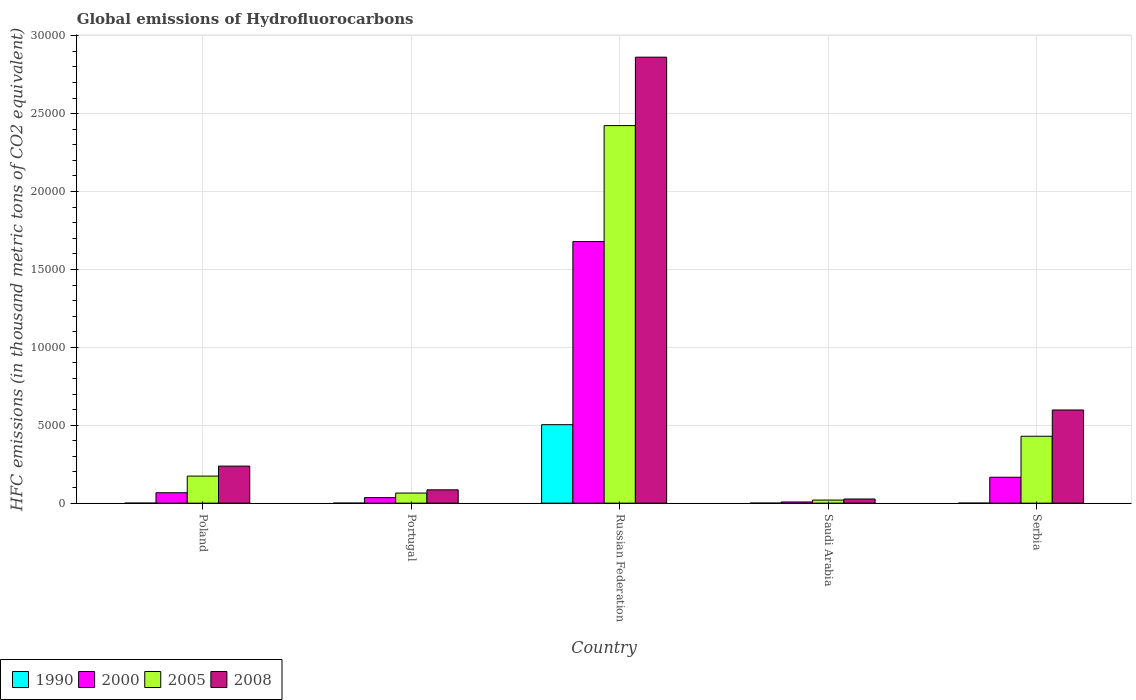How many different coloured bars are there?
Make the answer very short. 4. How many groups of bars are there?
Give a very brief answer. 5. How many bars are there on the 2nd tick from the left?
Make the answer very short. 4. What is the label of the 4th group of bars from the left?
Make the answer very short. Saudi Arabia. In how many cases, is the number of bars for a given country not equal to the number of legend labels?
Your answer should be compact. 0. What is the global emissions of Hydrofluorocarbons in 1990 in Poland?
Provide a succinct answer. 0.1. Across all countries, what is the maximum global emissions of Hydrofluorocarbons in 1990?
Provide a short and direct response. 5035.6. Across all countries, what is the minimum global emissions of Hydrofluorocarbons in 2005?
Offer a terse response. 196.9. In which country was the global emissions of Hydrofluorocarbons in 2008 maximum?
Your answer should be very brief. Russian Federation. In which country was the global emissions of Hydrofluorocarbons in 2000 minimum?
Your response must be concise. Saudi Arabia. What is the total global emissions of Hydrofluorocarbons in 2005 in the graph?
Your response must be concise. 3.11e+04. What is the difference between the global emissions of Hydrofluorocarbons in 2008 in Poland and that in Russian Federation?
Your answer should be compact. -2.62e+04. What is the difference between the global emissions of Hydrofluorocarbons in 1990 in Portugal and the global emissions of Hydrofluorocarbons in 2005 in Saudi Arabia?
Your response must be concise. -196.7. What is the average global emissions of Hydrofluorocarbons in 1990 per country?
Provide a short and direct response. 1007.3. What is the difference between the global emissions of Hydrofluorocarbons of/in 2000 and global emissions of Hydrofluorocarbons of/in 2005 in Russian Federation?
Your response must be concise. -7442.6. What is the ratio of the global emissions of Hydrofluorocarbons in 2008 in Poland to that in Saudi Arabia?
Provide a succinct answer. 8.92. Is the difference between the global emissions of Hydrofluorocarbons in 2000 in Russian Federation and Saudi Arabia greater than the difference between the global emissions of Hydrofluorocarbons in 2005 in Russian Federation and Saudi Arabia?
Make the answer very short. No. What is the difference between the highest and the second highest global emissions of Hydrofluorocarbons in 1990?
Provide a short and direct response. -5035.1. What is the difference between the highest and the lowest global emissions of Hydrofluorocarbons in 2000?
Keep it short and to the point. 1.67e+04. In how many countries, is the global emissions of Hydrofluorocarbons in 2005 greater than the average global emissions of Hydrofluorocarbons in 2005 taken over all countries?
Keep it short and to the point. 1. Is the sum of the global emissions of Hydrofluorocarbons in 1990 in Portugal and Russian Federation greater than the maximum global emissions of Hydrofluorocarbons in 2008 across all countries?
Your answer should be very brief. No. Is it the case that in every country, the sum of the global emissions of Hydrofluorocarbons in 2008 and global emissions of Hydrofluorocarbons in 2005 is greater than the sum of global emissions of Hydrofluorocarbons in 1990 and global emissions of Hydrofluorocarbons in 2000?
Make the answer very short. No. What does the 4th bar from the right in Poland represents?
Make the answer very short. 1990. Is it the case that in every country, the sum of the global emissions of Hydrofluorocarbons in 1990 and global emissions of Hydrofluorocarbons in 2008 is greater than the global emissions of Hydrofluorocarbons in 2005?
Provide a succinct answer. Yes. Are all the bars in the graph horizontal?
Provide a succinct answer. No. What is the difference between two consecutive major ticks on the Y-axis?
Provide a succinct answer. 5000. Are the values on the major ticks of Y-axis written in scientific E-notation?
Provide a succinct answer. No. Does the graph contain any zero values?
Provide a succinct answer. No. Does the graph contain grids?
Your answer should be very brief. Yes. Where does the legend appear in the graph?
Offer a very short reply. Bottom left. How are the legend labels stacked?
Keep it short and to the point. Horizontal. What is the title of the graph?
Make the answer very short. Global emissions of Hydrofluorocarbons. Does "1973" appear as one of the legend labels in the graph?
Your answer should be very brief. No. What is the label or title of the Y-axis?
Ensure brevity in your answer.  HFC emissions (in thousand metric tons of CO2 equivalent). What is the HFC emissions (in thousand metric tons of CO2 equivalent) in 2000 in Poland?
Provide a succinct answer. 667.2. What is the HFC emissions (in thousand metric tons of CO2 equivalent) of 2005 in Poland?
Keep it short and to the point. 1736.7. What is the HFC emissions (in thousand metric tons of CO2 equivalent) of 2008 in Poland?
Ensure brevity in your answer.  2378. What is the HFC emissions (in thousand metric tons of CO2 equivalent) in 1990 in Portugal?
Keep it short and to the point. 0.2. What is the HFC emissions (in thousand metric tons of CO2 equivalent) in 2000 in Portugal?
Your response must be concise. 352.7. What is the HFC emissions (in thousand metric tons of CO2 equivalent) of 2005 in Portugal?
Your answer should be compact. 647.7. What is the HFC emissions (in thousand metric tons of CO2 equivalent) of 2008 in Portugal?
Your answer should be very brief. 854.4. What is the HFC emissions (in thousand metric tons of CO2 equivalent) in 1990 in Russian Federation?
Ensure brevity in your answer.  5035.6. What is the HFC emissions (in thousand metric tons of CO2 equivalent) of 2000 in Russian Federation?
Offer a very short reply. 1.68e+04. What is the HFC emissions (in thousand metric tons of CO2 equivalent) of 2005 in Russian Federation?
Make the answer very short. 2.42e+04. What is the HFC emissions (in thousand metric tons of CO2 equivalent) in 2008 in Russian Federation?
Your answer should be very brief. 2.86e+04. What is the HFC emissions (in thousand metric tons of CO2 equivalent) of 1990 in Saudi Arabia?
Your response must be concise. 0.1. What is the HFC emissions (in thousand metric tons of CO2 equivalent) in 2000 in Saudi Arabia?
Your answer should be very brief. 75.5. What is the HFC emissions (in thousand metric tons of CO2 equivalent) in 2005 in Saudi Arabia?
Your answer should be very brief. 196.9. What is the HFC emissions (in thousand metric tons of CO2 equivalent) in 2008 in Saudi Arabia?
Your response must be concise. 266.5. What is the HFC emissions (in thousand metric tons of CO2 equivalent) of 1990 in Serbia?
Offer a terse response. 0.5. What is the HFC emissions (in thousand metric tons of CO2 equivalent) of 2000 in Serbia?
Your response must be concise. 1662. What is the HFC emissions (in thousand metric tons of CO2 equivalent) in 2005 in Serbia?
Provide a short and direct response. 4293.8. What is the HFC emissions (in thousand metric tons of CO2 equivalent) of 2008 in Serbia?
Offer a terse response. 5979. Across all countries, what is the maximum HFC emissions (in thousand metric tons of CO2 equivalent) of 1990?
Your answer should be very brief. 5035.6. Across all countries, what is the maximum HFC emissions (in thousand metric tons of CO2 equivalent) of 2000?
Your answer should be compact. 1.68e+04. Across all countries, what is the maximum HFC emissions (in thousand metric tons of CO2 equivalent) in 2005?
Keep it short and to the point. 2.42e+04. Across all countries, what is the maximum HFC emissions (in thousand metric tons of CO2 equivalent) in 2008?
Your answer should be compact. 2.86e+04. Across all countries, what is the minimum HFC emissions (in thousand metric tons of CO2 equivalent) in 1990?
Make the answer very short. 0.1. Across all countries, what is the minimum HFC emissions (in thousand metric tons of CO2 equivalent) of 2000?
Your response must be concise. 75.5. Across all countries, what is the minimum HFC emissions (in thousand metric tons of CO2 equivalent) in 2005?
Your response must be concise. 196.9. Across all countries, what is the minimum HFC emissions (in thousand metric tons of CO2 equivalent) in 2008?
Offer a terse response. 266.5. What is the total HFC emissions (in thousand metric tons of CO2 equivalent) of 1990 in the graph?
Offer a terse response. 5036.5. What is the total HFC emissions (in thousand metric tons of CO2 equivalent) in 2000 in the graph?
Offer a very short reply. 1.95e+04. What is the total HFC emissions (in thousand metric tons of CO2 equivalent) in 2005 in the graph?
Keep it short and to the point. 3.11e+04. What is the total HFC emissions (in thousand metric tons of CO2 equivalent) in 2008 in the graph?
Your answer should be very brief. 3.81e+04. What is the difference between the HFC emissions (in thousand metric tons of CO2 equivalent) in 1990 in Poland and that in Portugal?
Make the answer very short. -0.1. What is the difference between the HFC emissions (in thousand metric tons of CO2 equivalent) of 2000 in Poland and that in Portugal?
Your response must be concise. 314.5. What is the difference between the HFC emissions (in thousand metric tons of CO2 equivalent) of 2005 in Poland and that in Portugal?
Your response must be concise. 1089. What is the difference between the HFC emissions (in thousand metric tons of CO2 equivalent) of 2008 in Poland and that in Portugal?
Provide a short and direct response. 1523.6. What is the difference between the HFC emissions (in thousand metric tons of CO2 equivalent) in 1990 in Poland and that in Russian Federation?
Ensure brevity in your answer.  -5035.5. What is the difference between the HFC emissions (in thousand metric tons of CO2 equivalent) in 2000 in Poland and that in Russian Federation?
Offer a terse response. -1.61e+04. What is the difference between the HFC emissions (in thousand metric tons of CO2 equivalent) of 2005 in Poland and that in Russian Federation?
Ensure brevity in your answer.  -2.25e+04. What is the difference between the HFC emissions (in thousand metric tons of CO2 equivalent) in 2008 in Poland and that in Russian Federation?
Your answer should be compact. -2.62e+04. What is the difference between the HFC emissions (in thousand metric tons of CO2 equivalent) of 1990 in Poland and that in Saudi Arabia?
Your answer should be very brief. 0. What is the difference between the HFC emissions (in thousand metric tons of CO2 equivalent) in 2000 in Poland and that in Saudi Arabia?
Give a very brief answer. 591.7. What is the difference between the HFC emissions (in thousand metric tons of CO2 equivalent) of 2005 in Poland and that in Saudi Arabia?
Provide a short and direct response. 1539.8. What is the difference between the HFC emissions (in thousand metric tons of CO2 equivalent) in 2008 in Poland and that in Saudi Arabia?
Make the answer very short. 2111.5. What is the difference between the HFC emissions (in thousand metric tons of CO2 equivalent) in 1990 in Poland and that in Serbia?
Your answer should be compact. -0.4. What is the difference between the HFC emissions (in thousand metric tons of CO2 equivalent) in 2000 in Poland and that in Serbia?
Provide a succinct answer. -994.8. What is the difference between the HFC emissions (in thousand metric tons of CO2 equivalent) in 2005 in Poland and that in Serbia?
Provide a succinct answer. -2557.1. What is the difference between the HFC emissions (in thousand metric tons of CO2 equivalent) of 2008 in Poland and that in Serbia?
Provide a succinct answer. -3601. What is the difference between the HFC emissions (in thousand metric tons of CO2 equivalent) in 1990 in Portugal and that in Russian Federation?
Make the answer very short. -5035.4. What is the difference between the HFC emissions (in thousand metric tons of CO2 equivalent) in 2000 in Portugal and that in Russian Federation?
Keep it short and to the point. -1.64e+04. What is the difference between the HFC emissions (in thousand metric tons of CO2 equivalent) of 2005 in Portugal and that in Russian Federation?
Your answer should be very brief. -2.36e+04. What is the difference between the HFC emissions (in thousand metric tons of CO2 equivalent) of 2008 in Portugal and that in Russian Federation?
Offer a terse response. -2.78e+04. What is the difference between the HFC emissions (in thousand metric tons of CO2 equivalent) in 2000 in Portugal and that in Saudi Arabia?
Provide a succinct answer. 277.2. What is the difference between the HFC emissions (in thousand metric tons of CO2 equivalent) in 2005 in Portugal and that in Saudi Arabia?
Keep it short and to the point. 450.8. What is the difference between the HFC emissions (in thousand metric tons of CO2 equivalent) of 2008 in Portugal and that in Saudi Arabia?
Make the answer very short. 587.9. What is the difference between the HFC emissions (in thousand metric tons of CO2 equivalent) of 2000 in Portugal and that in Serbia?
Your response must be concise. -1309.3. What is the difference between the HFC emissions (in thousand metric tons of CO2 equivalent) in 2005 in Portugal and that in Serbia?
Your answer should be compact. -3646.1. What is the difference between the HFC emissions (in thousand metric tons of CO2 equivalent) in 2008 in Portugal and that in Serbia?
Your answer should be very brief. -5124.6. What is the difference between the HFC emissions (in thousand metric tons of CO2 equivalent) of 1990 in Russian Federation and that in Saudi Arabia?
Make the answer very short. 5035.5. What is the difference between the HFC emissions (in thousand metric tons of CO2 equivalent) of 2000 in Russian Federation and that in Saudi Arabia?
Give a very brief answer. 1.67e+04. What is the difference between the HFC emissions (in thousand metric tons of CO2 equivalent) of 2005 in Russian Federation and that in Saudi Arabia?
Ensure brevity in your answer.  2.40e+04. What is the difference between the HFC emissions (in thousand metric tons of CO2 equivalent) in 2008 in Russian Federation and that in Saudi Arabia?
Give a very brief answer. 2.84e+04. What is the difference between the HFC emissions (in thousand metric tons of CO2 equivalent) in 1990 in Russian Federation and that in Serbia?
Ensure brevity in your answer.  5035.1. What is the difference between the HFC emissions (in thousand metric tons of CO2 equivalent) in 2000 in Russian Federation and that in Serbia?
Make the answer very short. 1.51e+04. What is the difference between the HFC emissions (in thousand metric tons of CO2 equivalent) of 2005 in Russian Federation and that in Serbia?
Your response must be concise. 1.99e+04. What is the difference between the HFC emissions (in thousand metric tons of CO2 equivalent) in 2008 in Russian Federation and that in Serbia?
Your answer should be compact. 2.26e+04. What is the difference between the HFC emissions (in thousand metric tons of CO2 equivalent) in 1990 in Saudi Arabia and that in Serbia?
Your answer should be compact. -0.4. What is the difference between the HFC emissions (in thousand metric tons of CO2 equivalent) in 2000 in Saudi Arabia and that in Serbia?
Offer a terse response. -1586.5. What is the difference between the HFC emissions (in thousand metric tons of CO2 equivalent) in 2005 in Saudi Arabia and that in Serbia?
Offer a very short reply. -4096.9. What is the difference between the HFC emissions (in thousand metric tons of CO2 equivalent) of 2008 in Saudi Arabia and that in Serbia?
Ensure brevity in your answer.  -5712.5. What is the difference between the HFC emissions (in thousand metric tons of CO2 equivalent) in 1990 in Poland and the HFC emissions (in thousand metric tons of CO2 equivalent) in 2000 in Portugal?
Offer a very short reply. -352.6. What is the difference between the HFC emissions (in thousand metric tons of CO2 equivalent) of 1990 in Poland and the HFC emissions (in thousand metric tons of CO2 equivalent) of 2005 in Portugal?
Your answer should be very brief. -647.6. What is the difference between the HFC emissions (in thousand metric tons of CO2 equivalent) in 1990 in Poland and the HFC emissions (in thousand metric tons of CO2 equivalent) in 2008 in Portugal?
Keep it short and to the point. -854.3. What is the difference between the HFC emissions (in thousand metric tons of CO2 equivalent) in 2000 in Poland and the HFC emissions (in thousand metric tons of CO2 equivalent) in 2005 in Portugal?
Offer a terse response. 19.5. What is the difference between the HFC emissions (in thousand metric tons of CO2 equivalent) of 2000 in Poland and the HFC emissions (in thousand metric tons of CO2 equivalent) of 2008 in Portugal?
Make the answer very short. -187.2. What is the difference between the HFC emissions (in thousand metric tons of CO2 equivalent) of 2005 in Poland and the HFC emissions (in thousand metric tons of CO2 equivalent) of 2008 in Portugal?
Make the answer very short. 882.3. What is the difference between the HFC emissions (in thousand metric tons of CO2 equivalent) in 1990 in Poland and the HFC emissions (in thousand metric tons of CO2 equivalent) in 2000 in Russian Federation?
Make the answer very short. -1.68e+04. What is the difference between the HFC emissions (in thousand metric tons of CO2 equivalent) in 1990 in Poland and the HFC emissions (in thousand metric tons of CO2 equivalent) in 2005 in Russian Federation?
Your answer should be very brief. -2.42e+04. What is the difference between the HFC emissions (in thousand metric tons of CO2 equivalent) of 1990 in Poland and the HFC emissions (in thousand metric tons of CO2 equivalent) of 2008 in Russian Federation?
Make the answer very short. -2.86e+04. What is the difference between the HFC emissions (in thousand metric tons of CO2 equivalent) in 2000 in Poland and the HFC emissions (in thousand metric tons of CO2 equivalent) in 2005 in Russian Federation?
Your answer should be compact. -2.36e+04. What is the difference between the HFC emissions (in thousand metric tons of CO2 equivalent) in 2000 in Poland and the HFC emissions (in thousand metric tons of CO2 equivalent) in 2008 in Russian Federation?
Make the answer very short. -2.80e+04. What is the difference between the HFC emissions (in thousand metric tons of CO2 equivalent) of 2005 in Poland and the HFC emissions (in thousand metric tons of CO2 equivalent) of 2008 in Russian Federation?
Your answer should be very brief. -2.69e+04. What is the difference between the HFC emissions (in thousand metric tons of CO2 equivalent) in 1990 in Poland and the HFC emissions (in thousand metric tons of CO2 equivalent) in 2000 in Saudi Arabia?
Give a very brief answer. -75.4. What is the difference between the HFC emissions (in thousand metric tons of CO2 equivalent) of 1990 in Poland and the HFC emissions (in thousand metric tons of CO2 equivalent) of 2005 in Saudi Arabia?
Ensure brevity in your answer.  -196.8. What is the difference between the HFC emissions (in thousand metric tons of CO2 equivalent) of 1990 in Poland and the HFC emissions (in thousand metric tons of CO2 equivalent) of 2008 in Saudi Arabia?
Your answer should be compact. -266.4. What is the difference between the HFC emissions (in thousand metric tons of CO2 equivalent) in 2000 in Poland and the HFC emissions (in thousand metric tons of CO2 equivalent) in 2005 in Saudi Arabia?
Make the answer very short. 470.3. What is the difference between the HFC emissions (in thousand metric tons of CO2 equivalent) of 2000 in Poland and the HFC emissions (in thousand metric tons of CO2 equivalent) of 2008 in Saudi Arabia?
Provide a succinct answer. 400.7. What is the difference between the HFC emissions (in thousand metric tons of CO2 equivalent) of 2005 in Poland and the HFC emissions (in thousand metric tons of CO2 equivalent) of 2008 in Saudi Arabia?
Offer a terse response. 1470.2. What is the difference between the HFC emissions (in thousand metric tons of CO2 equivalent) of 1990 in Poland and the HFC emissions (in thousand metric tons of CO2 equivalent) of 2000 in Serbia?
Your answer should be compact. -1661.9. What is the difference between the HFC emissions (in thousand metric tons of CO2 equivalent) in 1990 in Poland and the HFC emissions (in thousand metric tons of CO2 equivalent) in 2005 in Serbia?
Give a very brief answer. -4293.7. What is the difference between the HFC emissions (in thousand metric tons of CO2 equivalent) in 1990 in Poland and the HFC emissions (in thousand metric tons of CO2 equivalent) in 2008 in Serbia?
Ensure brevity in your answer.  -5978.9. What is the difference between the HFC emissions (in thousand metric tons of CO2 equivalent) in 2000 in Poland and the HFC emissions (in thousand metric tons of CO2 equivalent) in 2005 in Serbia?
Ensure brevity in your answer.  -3626.6. What is the difference between the HFC emissions (in thousand metric tons of CO2 equivalent) of 2000 in Poland and the HFC emissions (in thousand metric tons of CO2 equivalent) of 2008 in Serbia?
Make the answer very short. -5311.8. What is the difference between the HFC emissions (in thousand metric tons of CO2 equivalent) in 2005 in Poland and the HFC emissions (in thousand metric tons of CO2 equivalent) in 2008 in Serbia?
Your response must be concise. -4242.3. What is the difference between the HFC emissions (in thousand metric tons of CO2 equivalent) in 1990 in Portugal and the HFC emissions (in thousand metric tons of CO2 equivalent) in 2000 in Russian Federation?
Offer a terse response. -1.68e+04. What is the difference between the HFC emissions (in thousand metric tons of CO2 equivalent) of 1990 in Portugal and the HFC emissions (in thousand metric tons of CO2 equivalent) of 2005 in Russian Federation?
Keep it short and to the point. -2.42e+04. What is the difference between the HFC emissions (in thousand metric tons of CO2 equivalent) in 1990 in Portugal and the HFC emissions (in thousand metric tons of CO2 equivalent) in 2008 in Russian Federation?
Provide a short and direct response. -2.86e+04. What is the difference between the HFC emissions (in thousand metric tons of CO2 equivalent) in 2000 in Portugal and the HFC emissions (in thousand metric tons of CO2 equivalent) in 2005 in Russian Federation?
Ensure brevity in your answer.  -2.39e+04. What is the difference between the HFC emissions (in thousand metric tons of CO2 equivalent) of 2000 in Portugal and the HFC emissions (in thousand metric tons of CO2 equivalent) of 2008 in Russian Federation?
Offer a terse response. -2.83e+04. What is the difference between the HFC emissions (in thousand metric tons of CO2 equivalent) of 2005 in Portugal and the HFC emissions (in thousand metric tons of CO2 equivalent) of 2008 in Russian Federation?
Offer a terse response. -2.80e+04. What is the difference between the HFC emissions (in thousand metric tons of CO2 equivalent) of 1990 in Portugal and the HFC emissions (in thousand metric tons of CO2 equivalent) of 2000 in Saudi Arabia?
Your answer should be compact. -75.3. What is the difference between the HFC emissions (in thousand metric tons of CO2 equivalent) in 1990 in Portugal and the HFC emissions (in thousand metric tons of CO2 equivalent) in 2005 in Saudi Arabia?
Make the answer very short. -196.7. What is the difference between the HFC emissions (in thousand metric tons of CO2 equivalent) in 1990 in Portugal and the HFC emissions (in thousand metric tons of CO2 equivalent) in 2008 in Saudi Arabia?
Provide a short and direct response. -266.3. What is the difference between the HFC emissions (in thousand metric tons of CO2 equivalent) of 2000 in Portugal and the HFC emissions (in thousand metric tons of CO2 equivalent) of 2005 in Saudi Arabia?
Ensure brevity in your answer.  155.8. What is the difference between the HFC emissions (in thousand metric tons of CO2 equivalent) in 2000 in Portugal and the HFC emissions (in thousand metric tons of CO2 equivalent) in 2008 in Saudi Arabia?
Make the answer very short. 86.2. What is the difference between the HFC emissions (in thousand metric tons of CO2 equivalent) of 2005 in Portugal and the HFC emissions (in thousand metric tons of CO2 equivalent) of 2008 in Saudi Arabia?
Offer a very short reply. 381.2. What is the difference between the HFC emissions (in thousand metric tons of CO2 equivalent) of 1990 in Portugal and the HFC emissions (in thousand metric tons of CO2 equivalent) of 2000 in Serbia?
Make the answer very short. -1661.8. What is the difference between the HFC emissions (in thousand metric tons of CO2 equivalent) of 1990 in Portugal and the HFC emissions (in thousand metric tons of CO2 equivalent) of 2005 in Serbia?
Provide a short and direct response. -4293.6. What is the difference between the HFC emissions (in thousand metric tons of CO2 equivalent) of 1990 in Portugal and the HFC emissions (in thousand metric tons of CO2 equivalent) of 2008 in Serbia?
Ensure brevity in your answer.  -5978.8. What is the difference between the HFC emissions (in thousand metric tons of CO2 equivalent) of 2000 in Portugal and the HFC emissions (in thousand metric tons of CO2 equivalent) of 2005 in Serbia?
Provide a succinct answer. -3941.1. What is the difference between the HFC emissions (in thousand metric tons of CO2 equivalent) of 2000 in Portugal and the HFC emissions (in thousand metric tons of CO2 equivalent) of 2008 in Serbia?
Provide a short and direct response. -5626.3. What is the difference between the HFC emissions (in thousand metric tons of CO2 equivalent) in 2005 in Portugal and the HFC emissions (in thousand metric tons of CO2 equivalent) in 2008 in Serbia?
Provide a succinct answer. -5331.3. What is the difference between the HFC emissions (in thousand metric tons of CO2 equivalent) of 1990 in Russian Federation and the HFC emissions (in thousand metric tons of CO2 equivalent) of 2000 in Saudi Arabia?
Give a very brief answer. 4960.1. What is the difference between the HFC emissions (in thousand metric tons of CO2 equivalent) in 1990 in Russian Federation and the HFC emissions (in thousand metric tons of CO2 equivalent) in 2005 in Saudi Arabia?
Keep it short and to the point. 4838.7. What is the difference between the HFC emissions (in thousand metric tons of CO2 equivalent) of 1990 in Russian Federation and the HFC emissions (in thousand metric tons of CO2 equivalent) of 2008 in Saudi Arabia?
Your answer should be very brief. 4769.1. What is the difference between the HFC emissions (in thousand metric tons of CO2 equivalent) of 2000 in Russian Federation and the HFC emissions (in thousand metric tons of CO2 equivalent) of 2005 in Saudi Arabia?
Provide a short and direct response. 1.66e+04. What is the difference between the HFC emissions (in thousand metric tons of CO2 equivalent) in 2000 in Russian Federation and the HFC emissions (in thousand metric tons of CO2 equivalent) in 2008 in Saudi Arabia?
Give a very brief answer. 1.65e+04. What is the difference between the HFC emissions (in thousand metric tons of CO2 equivalent) of 2005 in Russian Federation and the HFC emissions (in thousand metric tons of CO2 equivalent) of 2008 in Saudi Arabia?
Give a very brief answer. 2.40e+04. What is the difference between the HFC emissions (in thousand metric tons of CO2 equivalent) in 1990 in Russian Federation and the HFC emissions (in thousand metric tons of CO2 equivalent) in 2000 in Serbia?
Make the answer very short. 3373.6. What is the difference between the HFC emissions (in thousand metric tons of CO2 equivalent) in 1990 in Russian Federation and the HFC emissions (in thousand metric tons of CO2 equivalent) in 2005 in Serbia?
Provide a short and direct response. 741.8. What is the difference between the HFC emissions (in thousand metric tons of CO2 equivalent) in 1990 in Russian Federation and the HFC emissions (in thousand metric tons of CO2 equivalent) in 2008 in Serbia?
Your response must be concise. -943.4. What is the difference between the HFC emissions (in thousand metric tons of CO2 equivalent) in 2000 in Russian Federation and the HFC emissions (in thousand metric tons of CO2 equivalent) in 2005 in Serbia?
Ensure brevity in your answer.  1.25e+04. What is the difference between the HFC emissions (in thousand metric tons of CO2 equivalent) in 2000 in Russian Federation and the HFC emissions (in thousand metric tons of CO2 equivalent) in 2008 in Serbia?
Offer a terse response. 1.08e+04. What is the difference between the HFC emissions (in thousand metric tons of CO2 equivalent) of 2005 in Russian Federation and the HFC emissions (in thousand metric tons of CO2 equivalent) of 2008 in Serbia?
Make the answer very short. 1.83e+04. What is the difference between the HFC emissions (in thousand metric tons of CO2 equivalent) in 1990 in Saudi Arabia and the HFC emissions (in thousand metric tons of CO2 equivalent) in 2000 in Serbia?
Keep it short and to the point. -1661.9. What is the difference between the HFC emissions (in thousand metric tons of CO2 equivalent) of 1990 in Saudi Arabia and the HFC emissions (in thousand metric tons of CO2 equivalent) of 2005 in Serbia?
Make the answer very short. -4293.7. What is the difference between the HFC emissions (in thousand metric tons of CO2 equivalent) of 1990 in Saudi Arabia and the HFC emissions (in thousand metric tons of CO2 equivalent) of 2008 in Serbia?
Provide a succinct answer. -5978.9. What is the difference between the HFC emissions (in thousand metric tons of CO2 equivalent) of 2000 in Saudi Arabia and the HFC emissions (in thousand metric tons of CO2 equivalent) of 2005 in Serbia?
Provide a short and direct response. -4218.3. What is the difference between the HFC emissions (in thousand metric tons of CO2 equivalent) in 2000 in Saudi Arabia and the HFC emissions (in thousand metric tons of CO2 equivalent) in 2008 in Serbia?
Ensure brevity in your answer.  -5903.5. What is the difference between the HFC emissions (in thousand metric tons of CO2 equivalent) in 2005 in Saudi Arabia and the HFC emissions (in thousand metric tons of CO2 equivalent) in 2008 in Serbia?
Provide a succinct answer. -5782.1. What is the average HFC emissions (in thousand metric tons of CO2 equivalent) of 1990 per country?
Your response must be concise. 1007.3. What is the average HFC emissions (in thousand metric tons of CO2 equivalent) in 2000 per country?
Make the answer very short. 3909.22. What is the average HFC emissions (in thousand metric tons of CO2 equivalent) of 2005 per country?
Your answer should be compact. 6221.28. What is the average HFC emissions (in thousand metric tons of CO2 equivalent) in 2008 per country?
Provide a succinct answer. 7620.28. What is the difference between the HFC emissions (in thousand metric tons of CO2 equivalent) of 1990 and HFC emissions (in thousand metric tons of CO2 equivalent) of 2000 in Poland?
Your answer should be very brief. -667.1. What is the difference between the HFC emissions (in thousand metric tons of CO2 equivalent) of 1990 and HFC emissions (in thousand metric tons of CO2 equivalent) of 2005 in Poland?
Offer a very short reply. -1736.6. What is the difference between the HFC emissions (in thousand metric tons of CO2 equivalent) in 1990 and HFC emissions (in thousand metric tons of CO2 equivalent) in 2008 in Poland?
Offer a terse response. -2377.9. What is the difference between the HFC emissions (in thousand metric tons of CO2 equivalent) of 2000 and HFC emissions (in thousand metric tons of CO2 equivalent) of 2005 in Poland?
Give a very brief answer. -1069.5. What is the difference between the HFC emissions (in thousand metric tons of CO2 equivalent) in 2000 and HFC emissions (in thousand metric tons of CO2 equivalent) in 2008 in Poland?
Your answer should be very brief. -1710.8. What is the difference between the HFC emissions (in thousand metric tons of CO2 equivalent) of 2005 and HFC emissions (in thousand metric tons of CO2 equivalent) of 2008 in Poland?
Keep it short and to the point. -641.3. What is the difference between the HFC emissions (in thousand metric tons of CO2 equivalent) of 1990 and HFC emissions (in thousand metric tons of CO2 equivalent) of 2000 in Portugal?
Provide a succinct answer. -352.5. What is the difference between the HFC emissions (in thousand metric tons of CO2 equivalent) of 1990 and HFC emissions (in thousand metric tons of CO2 equivalent) of 2005 in Portugal?
Your response must be concise. -647.5. What is the difference between the HFC emissions (in thousand metric tons of CO2 equivalent) of 1990 and HFC emissions (in thousand metric tons of CO2 equivalent) of 2008 in Portugal?
Provide a succinct answer. -854.2. What is the difference between the HFC emissions (in thousand metric tons of CO2 equivalent) in 2000 and HFC emissions (in thousand metric tons of CO2 equivalent) in 2005 in Portugal?
Ensure brevity in your answer.  -295. What is the difference between the HFC emissions (in thousand metric tons of CO2 equivalent) of 2000 and HFC emissions (in thousand metric tons of CO2 equivalent) of 2008 in Portugal?
Your answer should be compact. -501.7. What is the difference between the HFC emissions (in thousand metric tons of CO2 equivalent) in 2005 and HFC emissions (in thousand metric tons of CO2 equivalent) in 2008 in Portugal?
Offer a terse response. -206.7. What is the difference between the HFC emissions (in thousand metric tons of CO2 equivalent) of 1990 and HFC emissions (in thousand metric tons of CO2 equivalent) of 2000 in Russian Federation?
Offer a very short reply. -1.18e+04. What is the difference between the HFC emissions (in thousand metric tons of CO2 equivalent) of 1990 and HFC emissions (in thousand metric tons of CO2 equivalent) of 2005 in Russian Federation?
Provide a short and direct response. -1.92e+04. What is the difference between the HFC emissions (in thousand metric tons of CO2 equivalent) of 1990 and HFC emissions (in thousand metric tons of CO2 equivalent) of 2008 in Russian Federation?
Your answer should be very brief. -2.36e+04. What is the difference between the HFC emissions (in thousand metric tons of CO2 equivalent) in 2000 and HFC emissions (in thousand metric tons of CO2 equivalent) in 2005 in Russian Federation?
Provide a succinct answer. -7442.6. What is the difference between the HFC emissions (in thousand metric tons of CO2 equivalent) of 2000 and HFC emissions (in thousand metric tons of CO2 equivalent) of 2008 in Russian Federation?
Make the answer very short. -1.18e+04. What is the difference between the HFC emissions (in thousand metric tons of CO2 equivalent) of 2005 and HFC emissions (in thousand metric tons of CO2 equivalent) of 2008 in Russian Federation?
Provide a short and direct response. -4392.2. What is the difference between the HFC emissions (in thousand metric tons of CO2 equivalent) in 1990 and HFC emissions (in thousand metric tons of CO2 equivalent) in 2000 in Saudi Arabia?
Ensure brevity in your answer.  -75.4. What is the difference between the HFC emissions (in thousand metric tons of CO2 equivalent) of 1990 and HFC emissions (in thousand metric tons of CO2 equivalent) of 2005 in Saudi Arabia?
Offer a terse response. -196.8. What is the difference between the HFC emissions (in thousand metric tons of CO2 equivalent) in 1990 and HFC emissions (in thousand metric tons of CO2 equivalent) in 2008 in Saudi Arabia?
Offer a very short reply. -266.4. What is the difference between the HFC emissions (in thousand metric tons of CO2 equivalent) of 2000 and HFC emissions (in thousand metric tons of CO2 equivalent) of 2005 in Saudi Arabia?
Ensure brevity in your answer.  -121.4. What is the difference between the HFC emissions (in thousand metric tons of CO2 equivalent) in 2000 and HFC emissions (in thousand metric tons of CO2 equivalent) in 2008 in Saudi Arabia?
Keep it short and to the point. -191. What is the difference between the HFC emissions (in thousand metric tons of CO2 equivalent) of 2005 and HFC emissions (in thousand metric tons of CO2 equivalent) of 2008 in Saudi Arabia?
Offer a terse response. -69.6. What is the difference between the HFC emissions (in thousand metric tons of CO2 equivalent) in 1990 and HFC emissions (in thousand metric tons of CO2 equivalent) in 2000 in Serbia?
Keep it short and to the point. -1661.5. What is the difference between the HFC emissions (in thousand metric tons of CO2 equivalent) in 1990 and HFC emissions (in thousand metric tons of CO2 equivalent) in 2005 in Serbia?
Your answer should be compact. -4293.3. What is the difference between the HFC emissions (in thousand metric tons of CO2 equivalent) of 1990 and HFC emissions (in thousand metric tons of CO2 equivalent) of 2008 in Serbia?
Offer a very short reply. -5978.5. What is the difference between the HFC emissions (in thousand metric tons of CO2 equivalent) of 2000 and HFC emissions (in thousand metric tons of CO2 equivalent) of 2005 in Serbia?
Provide a short and direct response. -2631.8. What is the difference between the HFC emissions (in thousand metric tons of CO2 equivalent) in 2000 and HFC emissions (in thousand metric tons of CO2 equivalent) in 2008 in Serbia?
Offer a very short reply. -4317. What is the difference between the HFC emissions (in thousand metric tons of CO2 equivalent) in 2005 and HFC emissions (in thousand metric tons of CO2 equivalent) in 2008 in Serbia?
Provide a succinct answer. -1685.2. What is the ratio of the HFC emissions (in thousand metric tons of CO2 equivalent) of 2000 in Poland to that in Portugal?
Make the answer very short. 1.89. What is the ratio of the HFC emissions (in thousand metric tons of CO2 equivalent) of 2005 in Poland to that in Portugal?
Offer a very short reply. 2.68. What is the ratio of the HFC emissions (in thousand metric tons of CO2 equivalent) of 2008 in Poland to that in Portugal?
Keep it short and to the point. 2.78. What is the ratio of the HFC emissions (in thousand metric tons of CO2 equivalent) of 2000 in Poland to that in Russian Federation?
Offer a terse response. 0.04. What is the ratio of the HFC emissions (in thousand metric tons of CO2 equivalent) of 2005 in Poland to that in Russian Federation?
Offer a very short reply. 0.07. What is the ratio of the HFC emissions (in thousand metric tons of CO2 equivalent) in 2008 in Poland to that in Russian Federation?
Provide a short and direct response. 0.08. What is the ratio of the HFC emissions (in thousand metric tons of CO2 equivalent) of 1990 in Poland to that in Saudi Arabia?
Keep it short and to the point. 1. What is the ratio of the HFC emissions (in thousand metric tons of CO2 equivalent) in 2000 in Poland to that in Saudi Arabia?
Offer a very short reply. 8.84. What is the ratio of the HFC emissions (in thousand metric tons of CO2 equivalent) of 2005 in Poland to that in Saudi Arabia?
Offer a very short reply. 8.82. What is the ratio of the HFC emissions (in thousand metric tons of CO2 equivalent) of 2008 in Poland to that in Saudi Arabia?
Provide a succinct answer. 8.92. What is the ratio of the HFC emissions (in thousand metric tons of CO2 equivalent) in 2000 in Poland to that in Serbia?
Offer a terse response. 0.4. What is the ratio of the HFC emissions (in thousand metric tons of CO2 equivalent) of 2005 in Poland to that in Serbia?
Offer a very short reply. 0.4. What is the ratio of the HFC emissions (in thousand metric tons of CO2 equivalent) of 2008 in Poland to that in Serbia?
Offer a very short reply. 0.4. What is the ratio of the HFC emissions (in thousand metric tons of CO2 equivalent) in 2000 in Portugal to that in Russian Federation?
Your response must be concise. 0.02. What is the ratio of the HFC emissions (in thousand metric tons of CO2 equivalent) in 2005 in Portugal to that in Russian Federation?
Your answer should be compact. 0.03. What is the ratio of the HFC emissions (in thousand metric tons of CO2 equivalent) in 2008 in Portugal to that in Russian Federation?
Make the answer very short. 0.03. What is the ratio of the HFC emissions (in thousand metric tons of CO2 equivalent) of 2000 in Portugal to that in Saudi Arabia?
Offer a very short reply. 4.67. What is the ratio of the HFC emissions (in thousand metric tons of CO2 equivalent) of 2005 in Portugal to that in Saudi Arabia?
Give a very brief answer. 3.29. What is the ratio of the HFC emissions (in thousand metric tons of CO2 equivalent) of 2008 in Portugal to that in Saudi Arabia?
Provide a short and direct response. 3.21. What is the ratio of the HFC emissions (in thousand metric tons of CO2 equivalent) of 1990 in Portugal to that in Serbia?
Make the answer very short. 0.4. What is the ratio of the HFC emissions (in thousand metric tons of CO2 equivalent) of 2000 in Portugal to that in Serbia?
Your answer should be very brief. 0.21. What is the ratio of the HFC emissions (in thousand metric tons of CO2 equivalent) in 2005 in Portugal to that in Serbia?
Make the answer very short. 0.15. What is the ratio of the HFC emissions (in thousand metric tons of CO2 equivalent) in 2008 in Portugal to that in Serbia?
Give a very brief answer. 0.14. What is the ratio of the HFC emissions (in thousand metric tons of CO2 equivalent) of 1990 in Russian Federation to that in Saudi Arabia?
Offer a terse response. 5.04e+04. What is the ratio of the HFC emissions (in thousand metric tons of CO2 equivalent) of 2000 in Russian Federation to that in Saudi Arabia?
Keep it short and to the point. 222.37. What is the ratio of the HFC emissions (in thousand metric tons of CO2 equivalent) in 2005 in Russian Federation to that in Saudi Arabia?
Provide a succinct answer. 123.06. What is the ratio of the HFC emissions (in thousand metric tons of CO2 equivalent) in 2008 in Russian Federation to that in Saudi Arabia?
Provide a short and direct response. 107.41. What is the ratio of the HFC emissions (in thousand metric tons of CO2 equivalent) of 1990 in Russian Federation to that in Serbia?
Provide a succinct answer. 1.01e+04. What is the ratio of the HFC emissions (in thousand metric tons of CO2 equivalent) of 2000 in Russian Federation to that in Serbia?
Make the answer very short. 10.1. What is the ratio of the HFC emissions (in thousand metric tons of CO2 equivalent) of 2005 in Russian Federation to that in Serbia?
Give a very brief answer. 5.64. What is the ratio of the HFC emissions (in thousand metric tons of CO2 equivalent) of 2008 in Russian Federation to that in Serbia?
Give a very brief answer. 4.79. What is the ratio of the HFC emissions (in thousand metric tons of CO2 equivalent) in 2000 in Saudi Arabia to that in Serbia?
Keep it short and to the point. 0.05. What is the ratio of the HFC emissions (in thousand metric tons of CO2 equivalent) of 2005 in Saudi Arabia to that in Serbia?
Make the answer very short. 0.05. What is the ratio of the HFC emissions (in thousand metric tons of CO2 equivalent) of 2008 in Saudi Arabia to that in Serbia?
Offer a very short reply. 0.04. What is the difference between the highest and the second highest HFC emissions (in thousand metric tons of CO2 equivalent) in 1990?
Provide a succinct answer. 5035.1. What is the difference between the highest and the second highest HFC emissions (in thousand metric tons of CO2 equivalent) in 2000?
Offer a terse response. 1.51e+04. What is the difference between the highest and the second highest HFC emissions (in thousand metric tons of CO2 equivalent) of 2005?
Provide a short and direct response. 1.99e+04. What is the difference between the highest and the second highest HFC emissions (in thousand metric tons of CO2 equivalent) in 2008?
Your answer should be very brief. 2.26e+04. What is the difference between the highest and the lowest HFC emissions (in thousand metric tons of CO2 equivalent) of 1990?
Give a very brief answer. 5035.5. What is the difference between the highest and the lowest HFC emissions (in thousand metric tons of CO2 equivalent) in 2000?
Offer a terse response. 1.67e+04. What is the difference between the highest and the lowest HFC emissions (in thousand metric tons of CO2 equivalent) in 2005?
Keep it short and to the point. 2.40e+04. What is the difference between the highest and the lowest HFC emissions (in thousand metric tons of CO2 equivalent) of 2008?
Your answer should be very brief. 2.84e+04. 